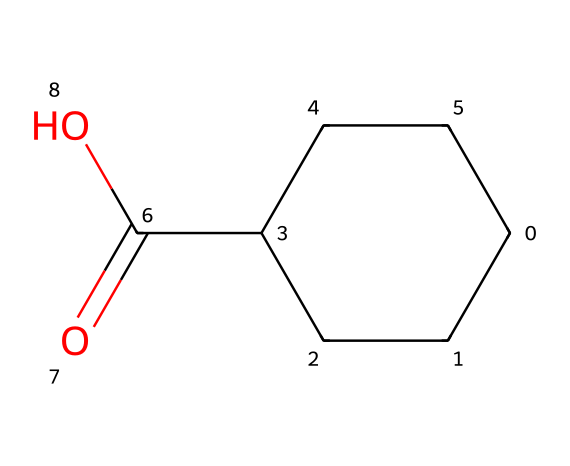What is the molecular formula of the compound? To find the molecular formula, count the number of each type of atom present in the SMILES. In this case, there are 6 carbon atoms (C) and 10 hydrogen atoms (H), plus 2 oxygen atoms (O). Therefore, the molecular formula is C6H10O2.
Answer: C6H10O2 How many carbon atoms are in the structure? Looking at the SMILES representation, the 'C' letters represent the carbon atoms. There are a total of 6 'C' in the SMILES notation.
Answer: 6 What kind of functional group is present in this molecule? The presence of the 'C(=O)O' part suggests that there is a carboxyl functional group (-COOH). This indicates that the molecule is a carboxylic acid.
Answer: carboxylic acid How many rings are present in the structure? The 'C1CCC(...)C1' notation indicates the presence of a cycloalkane ring. Hence, there is 1 cycloalkane ring in the structure.
Answer: 1 What is the degree of saturation of this molecule? The degree of saturation can be determined by the formula: (C - H/2 + N/2 + 1). Here C = 6 and H = 10, thus (6 - 10/2 + 0 + 1) gives 3, indicating the molecule is three degrees saturated.
Answer: 3 Is this molecule saturated or unsaturated? Given that it contains a cycloalkane structure and has no double bonds or rings other than the one present, it is considered a saturated compound.
Answer: saturated 